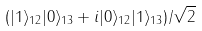Convert formula to latex. <formula><loc_0><loc_0><loc_500><loc_500>( | 1 \rangle _ { 1 2 } | 0 \rangle _ { 1 3 } + i | 0 \rangle _ { 1 2 } | 1 \rangle _ { 1 3 } ) / \sqrt { 2 }</formula> 